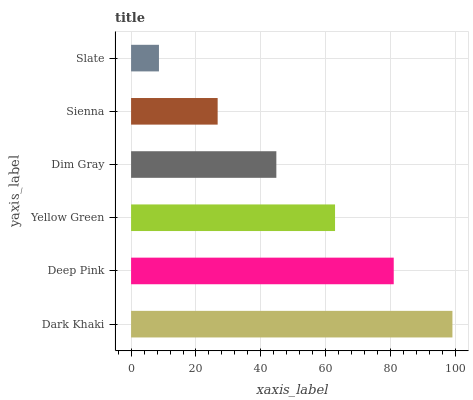Is Slate the minimum?
Answer yes or no. Yes. Is Dark Khaki the maximum?
Answer yes or no. Yes. Is Deep Pink the minimum?
Answer yes or no. No. Is Deep Pink the maximum?
Answer yes or no. No. Is Dark Khaki greater than Deep Pink?
Answer yes or no. Yes. Is Deep Pink less than Dark Khaki?
Answer yes or no. Yes. Is Deep Pink greater than Dark Khaki?
Answer yes or no. No. Is Dark Khaki less than Deep Pink?
Answer yes or no. No. Is Yellow Green the high median?
Answer yes or no. Yes. Is Dim Gray the low median?
Answer yes or no. Yes. Is Deep Pink the high median?
Answer yes or no. No. Is Sienna the low median?
Answer yes or no. No. 